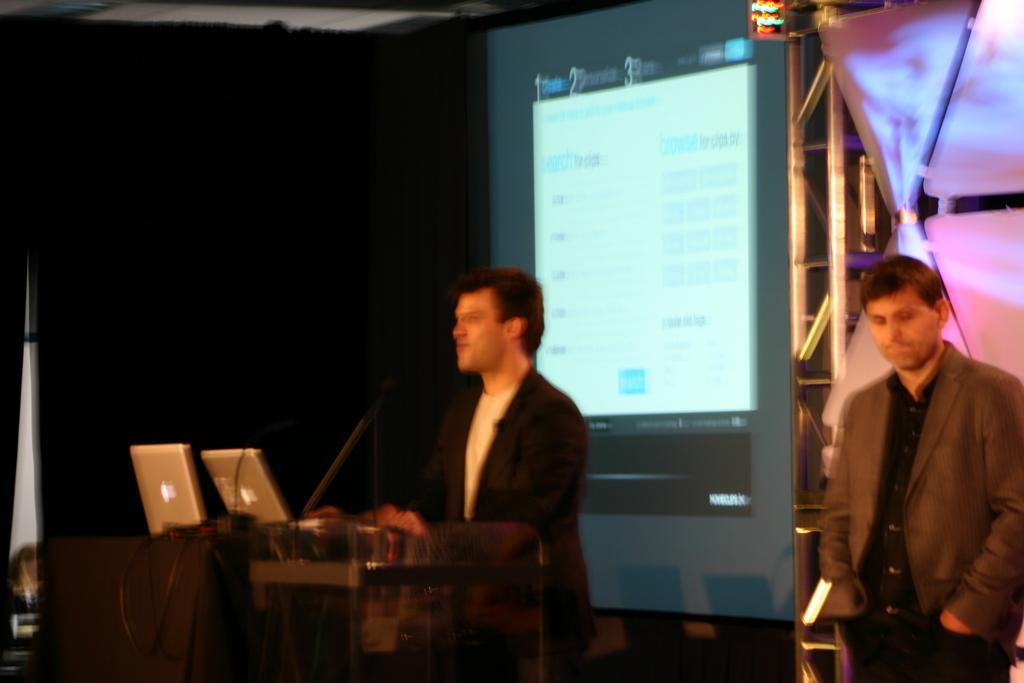Please provide a concise description of this image. This image consists of two persons in the middle. There is a podium in the middle. On that there are mac, laptops. There is a screen in the middle. 